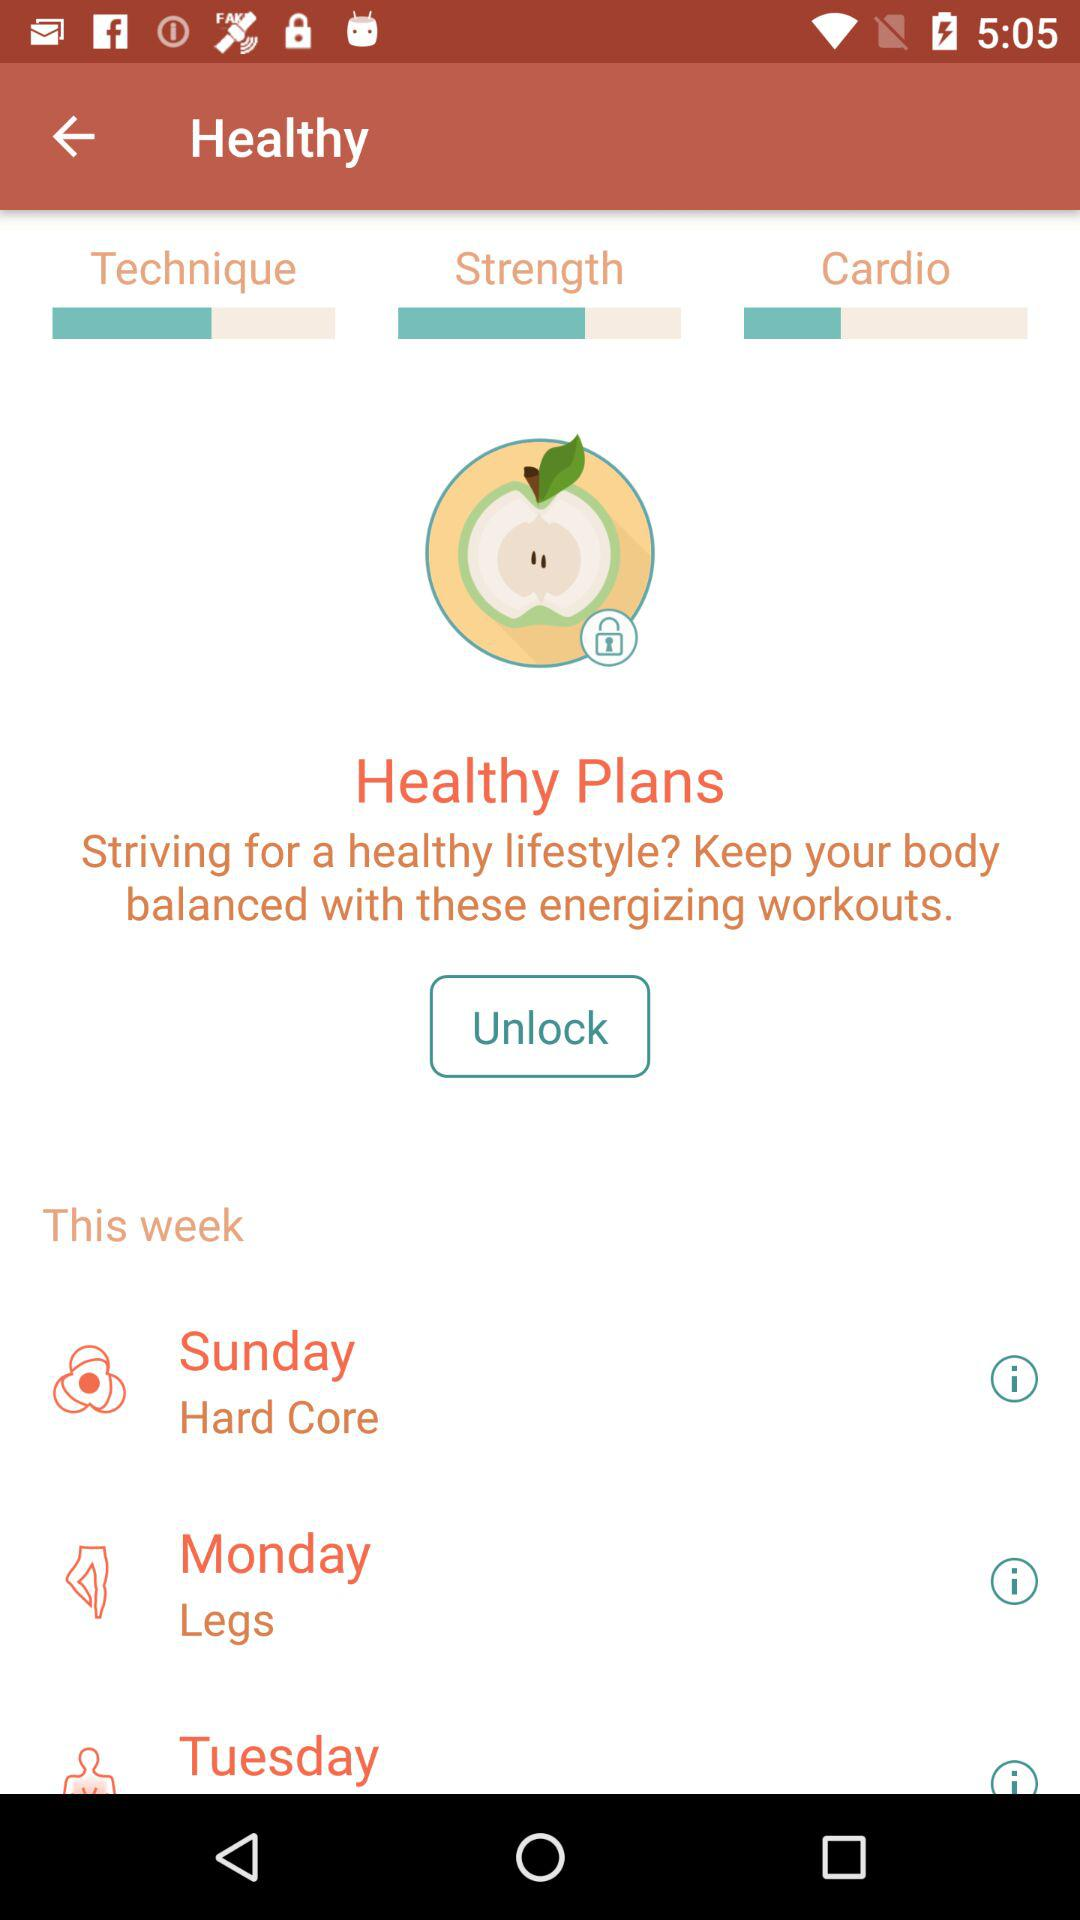How many workout plans are offered?
Answer the question using a single word or phrase. 3 